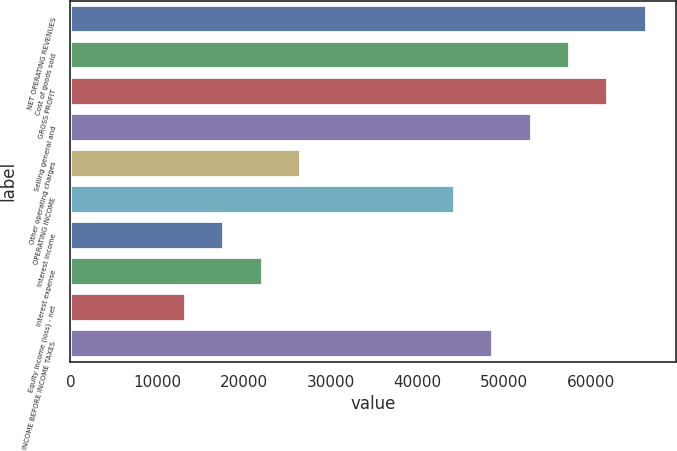<chart> <loc_0><loc_0><loc_500><loc_500><bar_chart><fcel>NET OPERATING REVENUES<fcel>Cost of goods sold<fcel>GROSS PROFIT<fcel>Selling general and<fcel>Other operating charges<fcel>OPERATING INCOME<fcel>Interest income<fcel>Interest expense<fcel>Equity income (loss) - net<fcel>INCOME BEFORE INCOME TAXES<nl><fcel>66440.1<fcel>57581.7<fcel>62010.9<fcel>53152.4<fcel>26577<fcel>44294<fcel>17718.6<fcel>22147.8<fcel>13289.4<fcel>48723.2<nl></chart> 